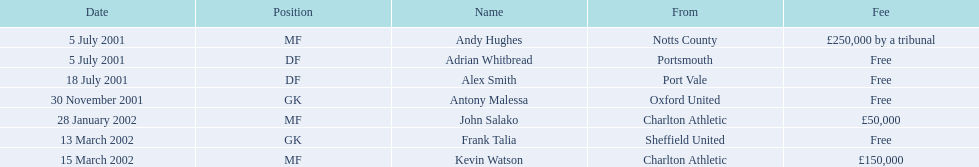What are the entire set of names? Andy Hughes, Adrian Whitbread, Alex Smith, Antony Malessa, John Salako, Frank Talia, Kevin Watson. What was the charge for each participant? £250,000 by a tribunal, Free, Free, Free, £50,000, Free, £150,000. And who had the top charge? Andy Hughes. What are the complete list of names? Andy Hughes, Adrian Whitbread, Alex Smith, Antony Malessa, John Salako, Frank Talia, Kevin Watson. What were the individual fees for each person? £250,000 by a tribunal, Free, Free, Free, £50,000, Free, £150,000. Who had the most expensive fee? Andy Hughes. Can you provide the names of everyone? Andy Hughes, Adrian Whitbread, Alex Smith, Antony Malessa, John Salako, Frank Talia, Kevin Watson. What was the cost for each individual? £250,000 by a tribunal, Free, Free, Free, £50,000, Free, £150,000. Who had the highest payment? Andy Hughes. 